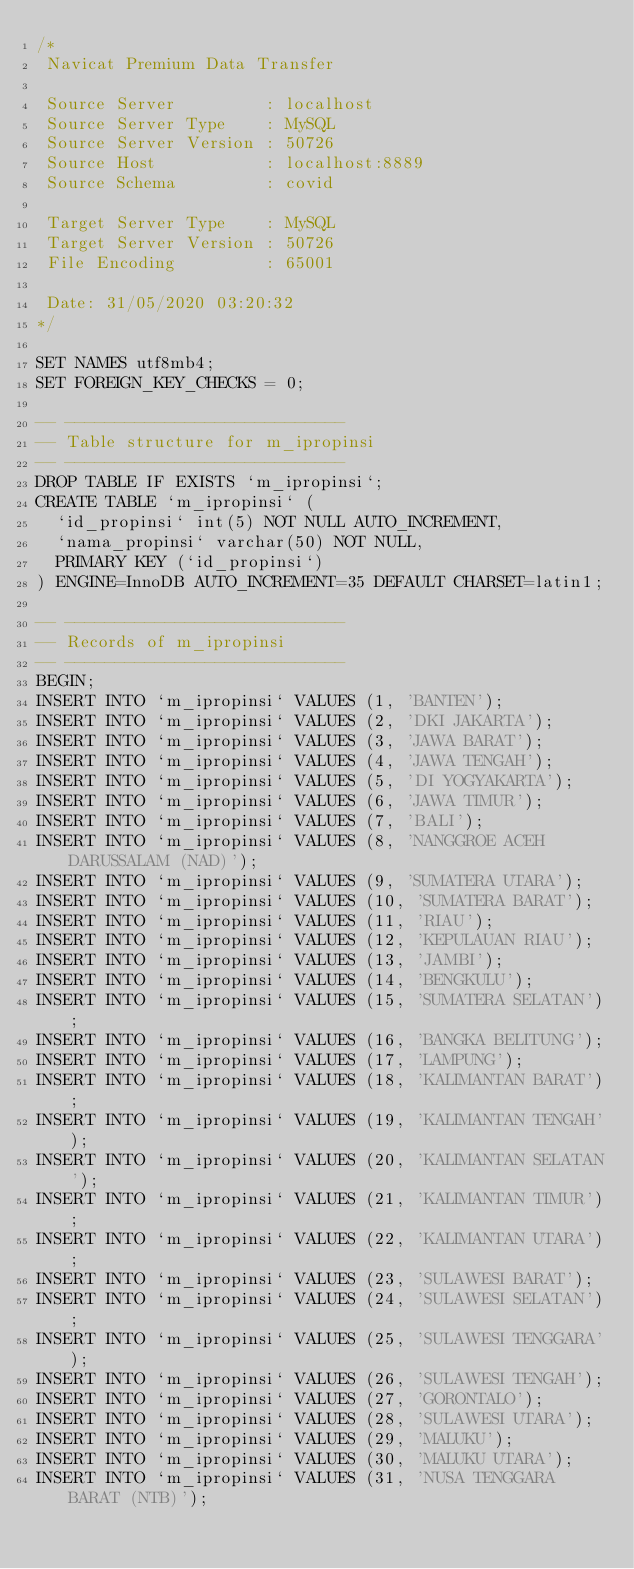<code> <loc_0><loc_0><loc_500><loc_500><_SQL_>/*
 Navicat Premium Data Transfer

 Source Server         : localhost
 Source Server Type    : MySQL
 Source Server Version : 50726
 Source Host           : localhost:8889
 Source Schema         : covid

 Target Server Type    : MySQL
 Target Server Version : 50726
 File Encoding         : 65001

 Date: 31/05/2020 03:20:32
*/

SET NAMES utf8mb4;
SET FOREIGN_KEY_CHECKS = 0;

-- ----------------------------
-- Table structure for m_ipropinsi
-- ----------------------------
DROP TABLE IF EXISTS `m_ipropinsi`;
CREATE TABLE `m_ipropinsi` (
  `id_propinsi` int(5) NOT NULL AUTO_INCREMENT,
  `nama_propinsi` varchar(50) NOT NULL,
  PRIMARY KEY (`id_propinsi`)
) ENGINE=InnoDB AUTO_INCREMENT=35 DEFAULT CHARSET=latin1;

-- ----------------------------
-- Records of m_ipropinsi
-- ----------------------------
BEGIN;
INSERT INTO `m_ipropinsi` VALUES (1, 'BANTEN');
INSERT INTO `m_ipropinsi` VALUES (2, 'DKI JAKARTA');
INSERT INTO `m_ipropinsi` VALUES (3, 'JAWA BARAT');
INSERT INTO `m_ipropinsi` VALUES (4, 'JAWA TENGAH');
INSERT INTO `m_ipropinsi` VALUES (5, 'DI YOGYAKARTA');
INSERT INTO `m_ipropinsi` VALUES (6, 'JAWA TIMUR');
INSERT INTO `m_ipropinsi` VALUES (7, 'BALI');
INSERT INTO `m_ipropinsi` VALUES (8, 'NANGGROE ACEH DARUSSALAM (NAD)');
INSERT INTO `m_ipropinsi` VALUES (9, 'SUMATERA UTARA');
INSERT INTO `m_ipropinsi` VALUES (10, 'SUMATERA BARAT');
INSERT INTO `m_ipropinsi` VALUES (11, 'RIAU');
INSERT INTO `m_ipropinsi` VALUES (12, 'KEPULAUAN RIAU');
INSERT INTO `m_ipropinsi` VALUES (13, 'JAMBI');
INSERT INTO `m_ipropinsi` VALUES (14, 'BENGKULU');
INSERT INTO `m_ipropinsi` VALUES (15, 'SUMATERA SELATAN');
INSERT INTO `m_ipropinsi` VALUES (16, 'BANGKA BELITUNG');
INSERT INTO `m_ipropinsi` VALUES (17, 'LAMPUNG');
INSERT INTO `m_ipropinsi` VALUES (18, 'KALIMANTAN BARAT');
INSERT INTO `m_ipropinsi` VALUES (19, 'KALIMANTAN TENGAH');
INSERT INTO `m_ipropinsi` VALUES (20, 'KALIMANTAN SELATAN');
INSERT INTO `m_ipropinsi` VALUES (21, 'KALIMANTAN TIMUR');
INSERT INTO `m_ipropinsi` VALUES (22, 'KALIMANTAN UTARA');
INSERT INTO `m_ipropinsi` VALUES (23, 'SULAWESI BARAT');
INSERT INTO `m_ipropinsi` VALUES (24, 'SULAWESI SELATAN');
INSERT INTO `m_ipropinsi` VALUES (25, 'SULAWESI TENGGARA');
INSERT INTO `m_ipropinsi` VALUES (26, 'SULAWESI TENGAH');
INSERT INTO `m_ipropinsi` VALUES (27, 'GORONTALO');
INSERT INTO `m_ipropinsi` VALUES (28, 'SULAWESI UTARA');
INSERT INTO `m_ipropinsi` VALUES (29, 'MALUKU');
INSERT INTO `m_ipropinsi` VALUES (30, 'MALUKU UTARA');
INSERT INTO `m_ipropinsi` VALUES (31, 'NUSA TENGGARA BARAT (NTB)');</code> 